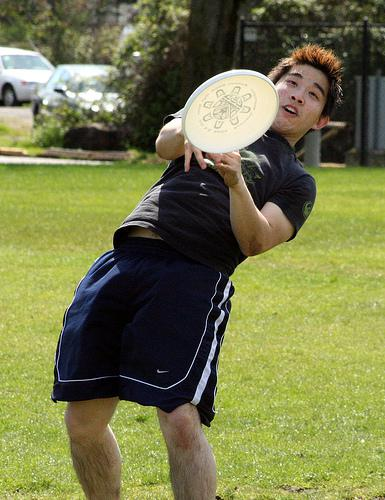Question: where is the tree?
Choices:
A. In the back.
B. The front.
C. A pot.
D. A nursery.
Answer with the letter. Answer: A Question: when was this photo taken?
Choices:
A. At night.
B. Morning.
C. New year's eve.
D. During the day.
Answer with the letter. Answer: D Question: why is the man bent over?
Choices:
A. Yard work.
B. Pick up baby.
C. Pain.
D. He's catching the frisbee.
Answer with the letter. Answer: D Question: how does the man look?
Choices:
A. Happy.
B. Sad.
C. Worried.
D. Angry.
Answer with the letter. Answer: A Question: what brand shorts is the man wearing?
Choices:
A. Nike.
B. Converse.
C. Vans.
D. Dc.
Answer with the letter. Answer: A 